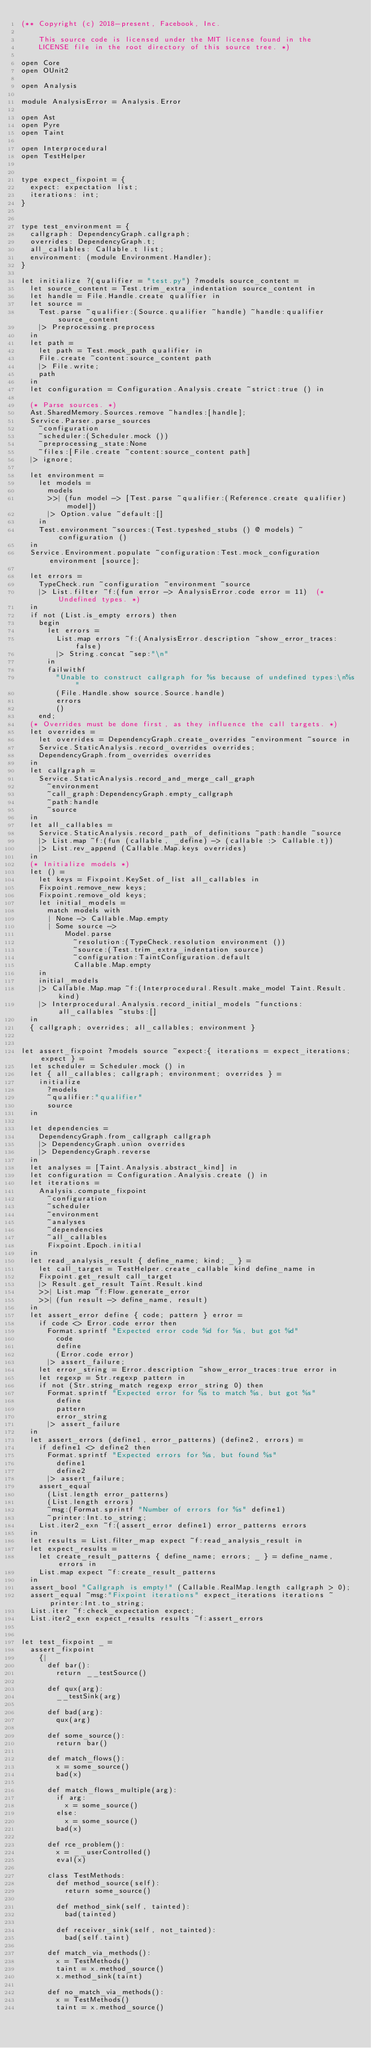Convert code to text. <code><loc_0><loc_0><loc_500><loc_500><_OCaml_>(** Copyright (c) 2018-present, Facebook, Inc.

    This source code is licensed under the MIT license found in the
    LICENSE file in the root directory of this source tree. *)

open Core
open OUnit2

open Analysis

module AnalysisError = Analysis.Error

open Ast
open Pyre
open Taint

open Interprocedural
open TestHelper


type expect_fixpoint = {
  expect: expectation list;
  iterations: int;
}


type test_environment = {
  callgraph: DependencyGraph.callgraph;
  overrides: DependencyGraph.t;
  all_callables: Callable.t list;
  environment: (module Environment.Handler);
}

let initialize ?(qualifier = "test.py") ?models source_content =
  let source_content = Test.trim_extra_indentation source_content in
  let handle = File.Handle.create qualifier in
  let source =
    Test.parse ~qualifier:(Source.qualifier ~handle) ~handle:qualifier source_content
    |> Preprocessing.preprocess
  in
  let path =
    let path = Test.mock_path qualifier in
    File.create ~content:source_content path
    |> File.write;
    path
  in
  let configuration = Configuration.Analysis.create ~strict:true () in

  (* Parse sources. *)
  Ast.SharedMemory.Sources.remove ~handles:[handle];
  Service.Parser.parse_sources
    ~configuration
    ~scheduler:(Scheduler.mock ())
    ~preprocessing_state:None
    ~files:[File.create ~content:source_content path]
  |> ignore;

  let environment =
    let models =
      models
      >>| (fun model -> [Test.parse ~qualifier:(Reference.create qualifier) model])
      |> Option.value ~default:[]
    in
    Test.environment ~sources:(Test.typeshed_stubs () @ models) ~configuration ()
  in
  Service.Environment.populate ~configuration:Test.mock_configuration environment [source];

  let errors =
    TypeCheck.run ~configuration ~environment ~source
    |> List.filter ~f:(fun error -> AnalysisError.code error = 11)  (* Undefined types. *)
  in
  if not (List.is_empty errors) then
    begin
      let errors =
        List.map errors ~f:(AnalysisError.description ~show_error_traces:false)
        |> String.concat ~sep:"\n"
      in
      failwithf
        "Unable to construct callgraph for %s because of undefined types:\n%s"
        (File.Handle.show source.Source.handle)
        errors
        ()
    end;
  (* Overrides must be done first, as they influence the call targets. *)
  let overrides =
    let overrides = DependencyGraph.create_overrides ~environment ~source in
    Service.StaticAnalysis.record_overrides overrides;
    DependencyGraph.from_overrides overrides
  in
  let callgraph =
    Service.StaticAnalysis.record_and_merge_call_graph
      ~environment
      ~call_graph:DependencyGraph.empty_callgraph
      ~path:handle
      ~source
  in
  let all_callables =
    Service.StaticAnalysis.record_path_of_definitions ~path:handle ~source
    |> List.map ~f:(fun (callable, _define) -> (callable :> Callable.t))
    |> List.rev_append (Callable.Map.keys overrides)
  in
  (* Initialize models *)
  let () =
    let keys = Fixpoint.KeySet.of_list all_callables in
    Fixpoint.remove_new keys;
    Fixpoint.remove_old keys;
    let initial_models =
      match models with
      | None -> Callable.Map.empty
      | Some source ->
          Model.parse
            ~resolution:(TypeCheck.resolution environment ())
            ~source:(Test.trim_extra_indentation source)
            ~configuration:TaintConfiguration.default
            Callable.Map.empty
    in
    initial_models
    |> Callable.Map.map ~f:(Interprocedural.Result.make_model Taint.Result.kind)
    |> Interprocedural.Analysis.record_initial_models ~functions:all_callables ~stubs:[]
  in
  { callgraph; overrides; all_callables; environment }


let assert_fixpoint ?models source ~expect:{ iterations = expect_iterations; expect } =
  let scheduler = Scheduler.mock () in
  let { all_callables; callgraph; environment; overrides } =
    initialize
      ?models
      ~qualifier:"qualifier"
      source
  in

  let dependencies =
    DependencyGraph.from_callgraph callgraph
    |> DependencyGraph.union overrides
    |> DependencyGraph.reverse
  in
  let analyses = [Taint.Analysis.abstract_kind] in
  let configuration = Configuration.Analysis.create () in
  let iterations =
    Analysis.compute_fixpoint
      ~configuration
      ~scheduler
      ~environment
      ~analyses
      ~dependencies
      ~all_callables
      Fixpoint.Epoch.initial
  in
  let read_analysis_result { define_name; kind; _ } =
    let call_target = TestHelper.create_callable kind define_name in
    Fixpoint.get_result call_target
    |> Result.get_result Taint.Result.kind
    >>| List.map ~f:Flow.generate_error
    >>| (fun result -> define_name, result)
  in
  let assert_error define { code; pattern } error =
    if code <> Error.code error then
      Format.sprintf "Expected error code %d for %s, but got %d"
        code
        define
        (Error.code error)
      |> assert_failure;
    let error_string = Error.description ~show_error_traces:true error in
    let regexp = Str.regexp pattern in
    if not (Str.string_match regexp error_string 0) then
      Format.sprintf "Expected error for %s to match %s, but got %s"
        define
        pattern
        error_string
      |> assert_failure
  in
  let assert_errors (define1, error_patterns) (define2, errors) =
    if define1 <> define2 then
      Format.sprintf "Expected errors for %s, but found %s"
        define1
        define2
      |> assert_failure;
    assert_equal
      (List.length error_patterns)
      (List.length errors)
      ~msg:(Format.sprintf "Number of errors for %s" define1)
      ~printer:Int.to_string;
    List.iter2_exn ~f:(assert_error define1) error_patterns errors
  in
  let results = List.filter_map expect ~f:read_analysis_result in
  let expect_results =
    let create_result_patterns { define_name; errors; _ } = define_name, errors in
    List.map expect ~f:create_result_patterns
  in
  assert_bool "Callgraph is empty!" (Callable.RealMap.length callgraph > 0);
  assert_equal ~msg:"Fixpoint iterations" expect_iterations iterations ~printer:Int.to_string;
  List.iter ~f:check_expectation expect;
  List.iter2_exn expect_results results ~f:assert_errors


let test_fixpoint _ =
  assert_fixpoint
    {|
      def bar():
        return __testSource()

      def qux(arg):
        __testSink(arg)

      def bad(arg):
        qux(arg)

      def some_source():
        return bar()

      def match_flows():
        x = some_source()
        bad(x)

      def match_flows_multiple(arg):
        if arg:
          x = some_source()
        else:
          x = some_source()
        bad(x)

      def rce_problem():
        x = __userControlled()
        eval(x)

      class TestMethods:
        def method_source(self):
          return some_source()

        def method_sink(self, tainted):
          bad(tainted)

        def receiver_sink(self, not_tainted):
          bad(self.taint)

      def match_via_methods():
        x = TestMethods()
        taint = x.method_source()
        x.method_sink(taint)

      def no_match_via_methods():
        x = TestMethods()
        taint = x.method_source()</code> 